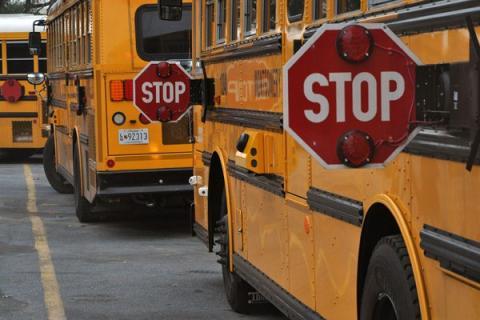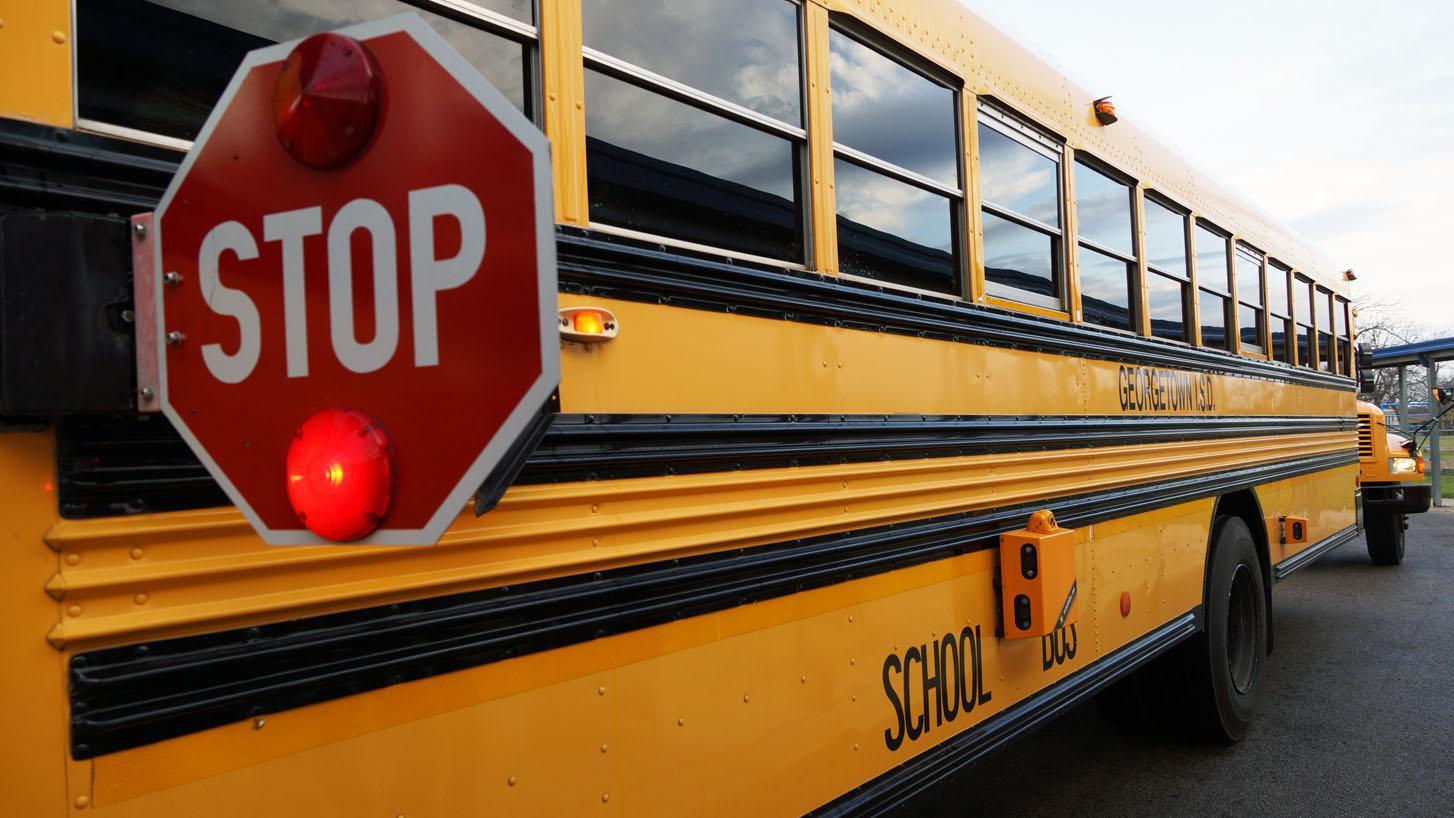The first image is the image on the left, the second image is the image on the right. Evaluate the accuracy of this statement regarding the images: "Each image includes a red octagonal sign with a word between two red lights on the top and bottom, and in one image, the top light appears illuminated.". Is it true? Answer yes or no. No. The first image is the image on the left, the second image is the image on the right. Evaluate the accuracy of this statement regarding the images: "Exactly two stop signs are extended.". Is it true? Answer yes or no. No. 